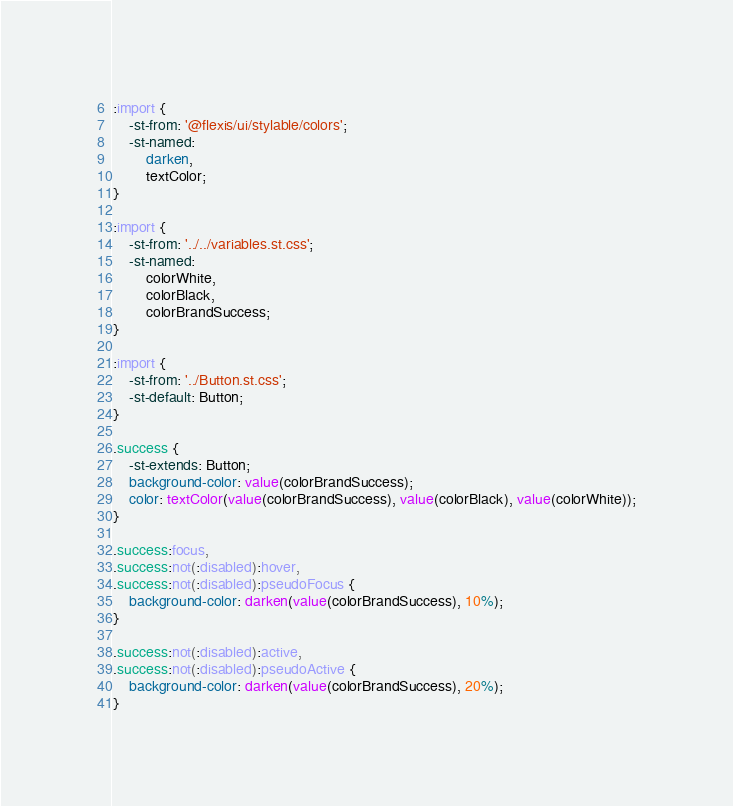Convert code to text. <code><loc_0><loc_0><loc_500><loc_500><_CSS_>
:import {
	-st-from: '@flexis/ui/stylable/colors';
	-st-named:
		darken,
		textColor;
}

:import {
	-st-from: '../../variables.st.css';
	-st-named:
		colorWhite,
		colorBlack,
		colorBrandSuccess;
}

:import {
	-st-from: '../Button.st.css';
	-st-default: Button;
}

.success {
	-st-extends: Button;
	background-color: value(colorBrandSuccess);
	color: textColor(value(colorBrandSuccess), value(colorBlack), value(colorWhite));
}

.success:focus,
.success:not(:disabled):hover,
.success:not(:disabled):pseudoFocus {
	background-color: darken(value(colorBrandSuccess), 10%);
}

.success:not(:disabled):active,
.success:not(:disabled):pseudoActive {
	background-color: darken(value(colorBrandSuccess), 20%);
}
</code> 